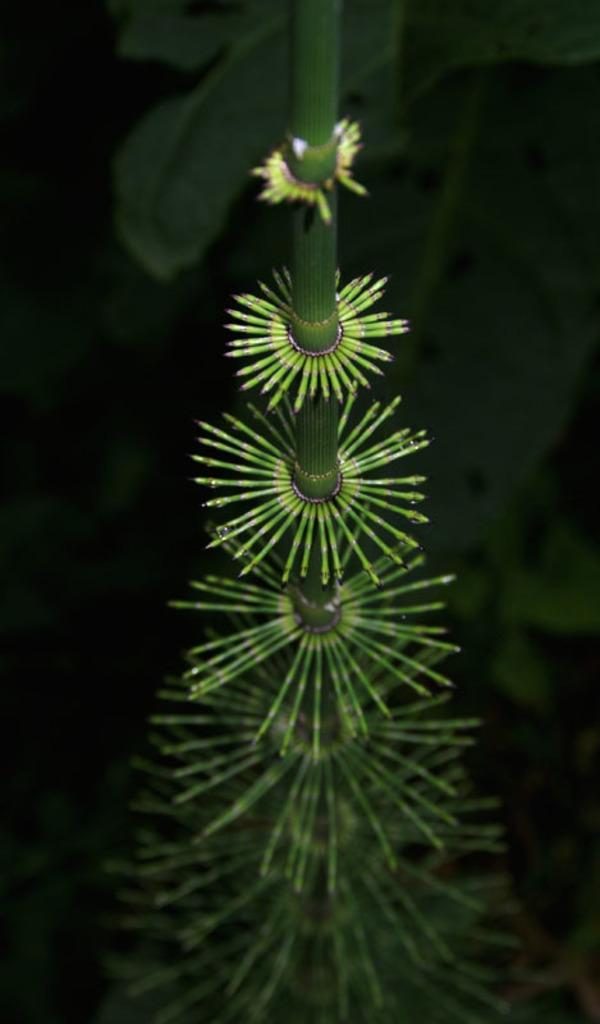What type of living organism can be seen in the image? There is a plant in the image. What is the color of the background in the image? The background of the image is dark. What type of can does the plant use to store water in the image? There is no can present in the image, and plants do not use cans to store water. 